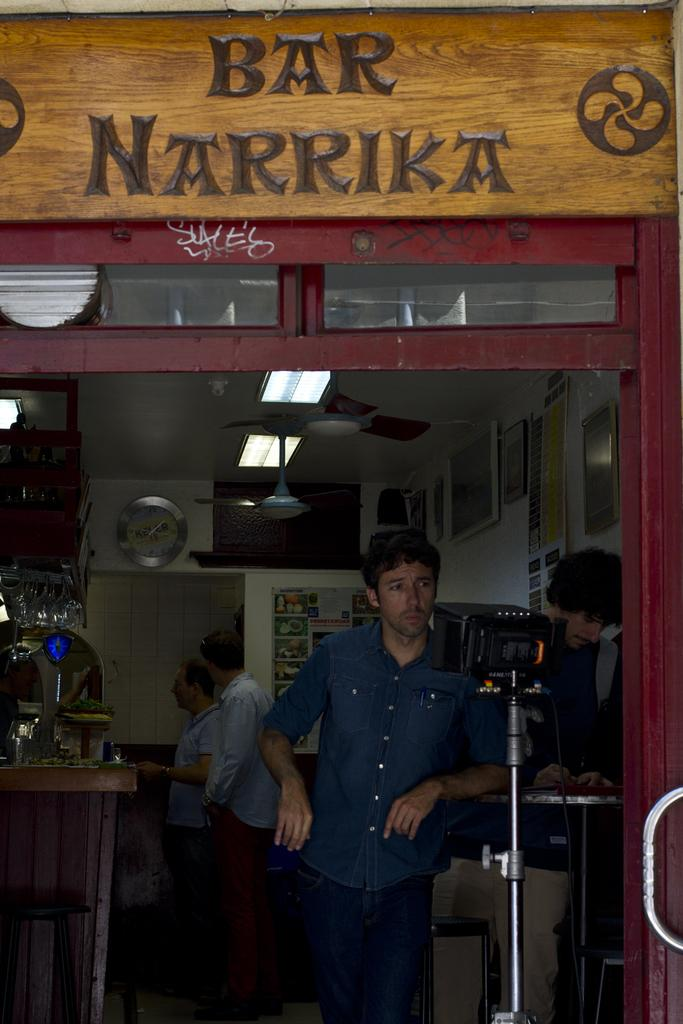<image>
Create a compact narrative representing the image presented. A man standing inside the doorway of Bar Narrika. 